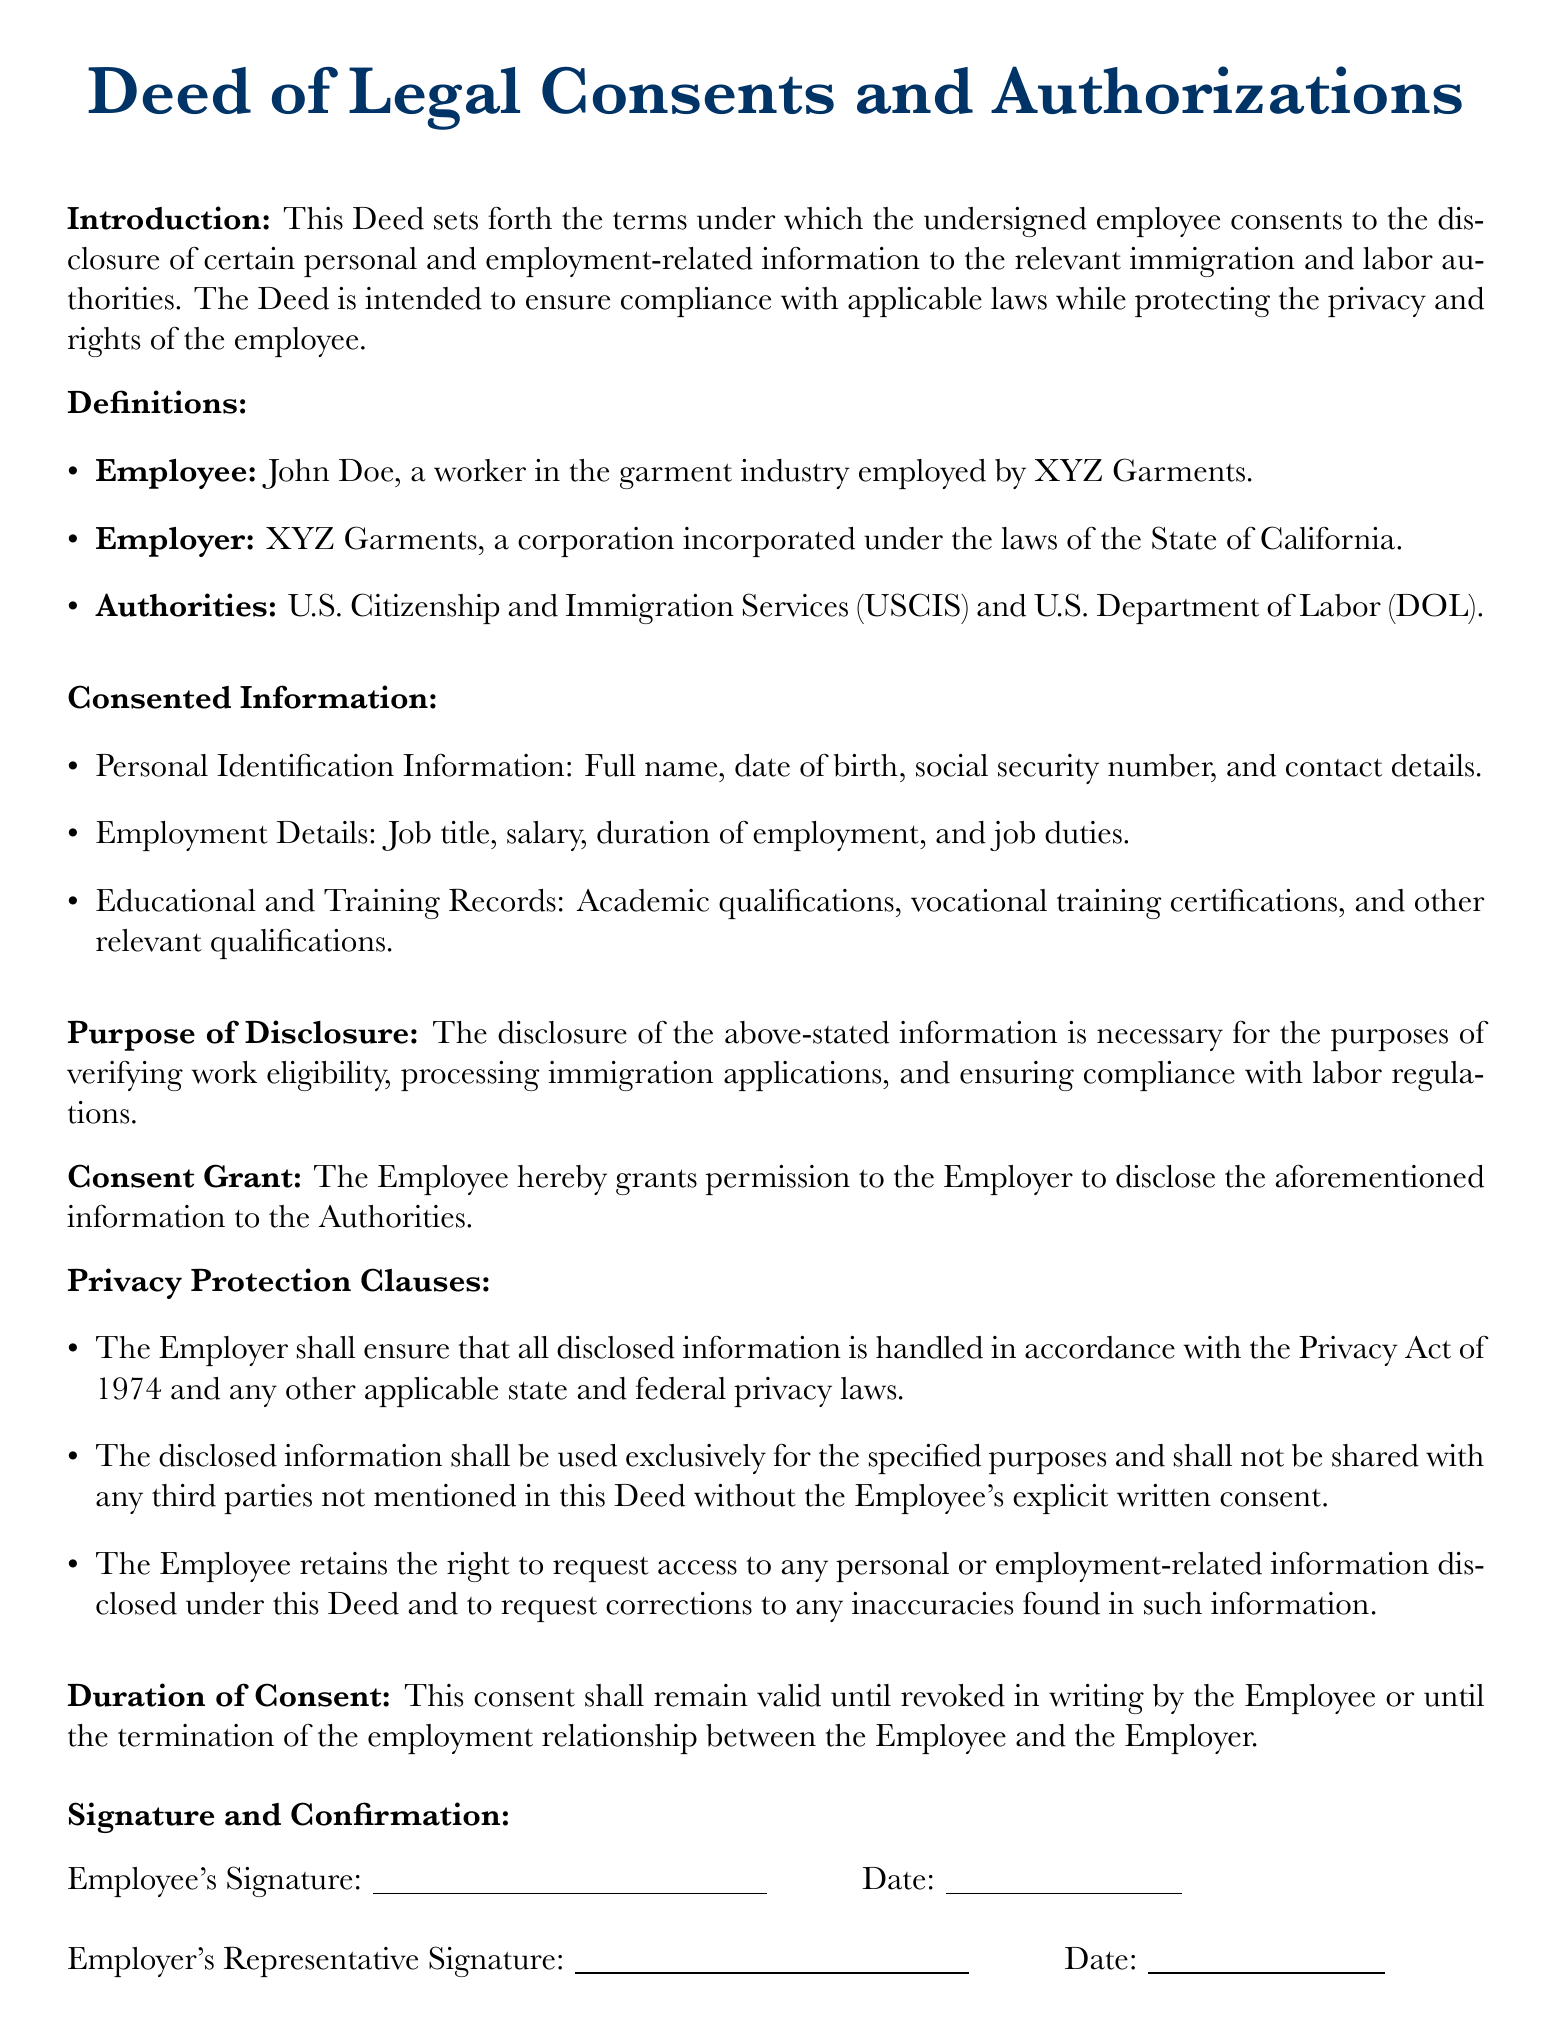What is the employee's name? The employee's name is mentioned in the "Definitions" section of the document as John Doe.
Answer: John Doe What is the employer's name? The employer's name is specified in the "Definitions" section as XYZ Garments.
Answer: XYZ Garments Which authorities are mentioned in this Deed? The authorities recognized in the document are listed in the "Definitions" section as USCIS and DOL.
Answer: USCIS and DOL What type of information is consented for disclosure? The "Consented Information" section outlines the types, including personal identification and employment details.
Answer: Personal Identification Information, Employment Details, Educational and Training Records What is the purpose of disclosure? The purpose of information disclosure is explained in the "Purpose of Disclosure" section, focusing on compliance and verification.
Answer: Verifying work eligibility, processing immigration applications, ensuring compliance with labor regulations How long does the consent remain valid? The "Duration of Consent" section states that the consent remains valid until revoked or the employment terminates.
Answer: Until revoked in writing or employment termination What privacy protection law is mentioned? The document refers to the Privacy Act of 1974 in the "Privacy Protection Clauses" section.
Answer: Privacy Act of 1974 What must the employer ensure regarding the disclosed information? The "Privacy Protection Clauses" mention that the employer must handle all disclosed information according to applicable privacy laws.
Answer: Handle in accordance with privacy laws How can the employee correct inaccuracies? The employee retains the right to request corrections as stated in the "Privacy Protection Clauses" section.
Answer: Request corrections to any inaccuracies Who signs the document? The document specifies two signatures: the Employee's Signature and the Employer's Representative Signature.
Answer: Employee and Employer's Representative 